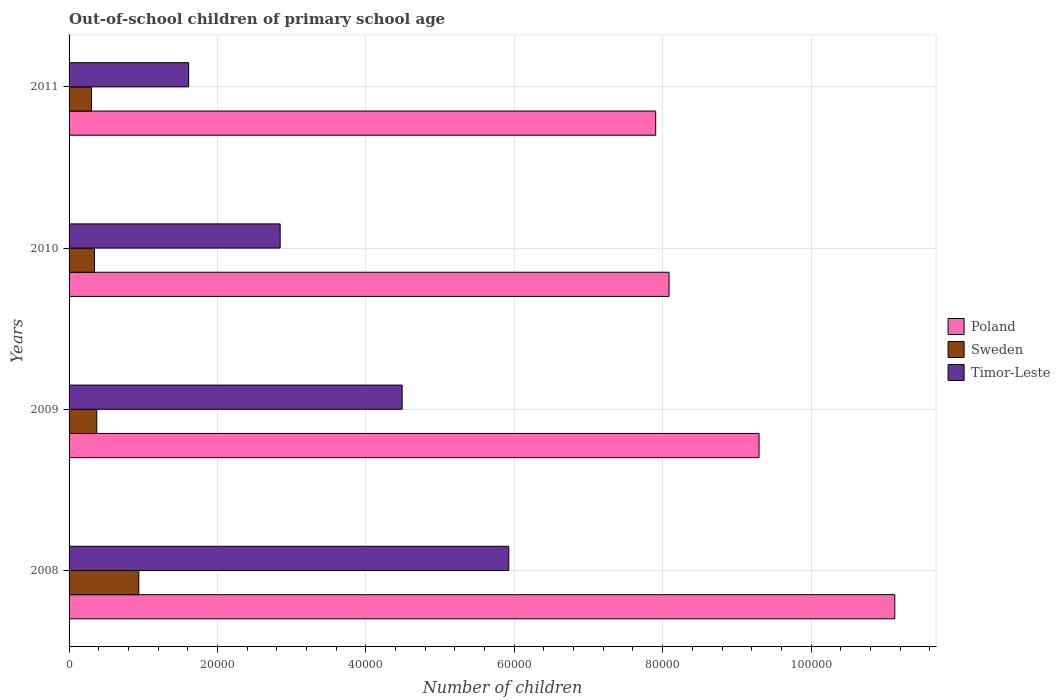How many different coloured bars are there?
Your answer should be very brief. 3. Are the number of bars per tick equal to the number of legend labels?
Offer a very short reply. Yes. Are the number of bars on each tick of the Y-axis equal?
Provide a short and direct response. Yes. What is the number of out-of-school children in Sweden in 2008?
Keep it short and to the point. 9399. Across all years, what is the maximum number of out-of-school children in Poland?
Offer a very short reply. 1.11e+05. Across all years, what is the minimum number of out-of-school children in Poland?
Offer a very short reply. 7.91e+04. In which year was the number of out-of-school children in Timor-Leste maximum?
Your response must be concise. 2008. In which year was the number of out-of-school children in Timor-Leste minimum?
Provide a short and direct response. 2011. What is the total number of out-of-school children in Poland in the graph?
Your response must be concise. 3.64e+05. What is the difference between the number of out-of-school children in Sweden in 2008 and that in 2011?
Provide a succinct answer. 6372. What is the difference between the number of out-of-school children in Poland in 2010 and the number of out-of-school children in Sweden in 2011?
Give a very brief answer. 7.78e+04. What is the average number of out-of-school children in Poland per year?
Your answer should be compact. 9.11e+04. In the year 2011, what is the difference between the number of out-of-school children in Timor-Leste and number of out-of-school children in Sweden?
Offer a very short reply. 1.31e+04. What is the ratio of the number of out-of-school children in Poland in 2008 to that in 2011?
Offer a terse response. 1.41. Is the difference between the number of out-of-school children in Timor-Leste in 2008 and 2010 greater than the difference between the number of out-of-school children in Sweden in 2008 and 2010?
Give a very brief answer. Yes. What is the difference between the highest and the second highest number of out-of-school children in Timor-Leste?
Your answer should be compact. 1.44e+04. What is the difference between the highest and the lowest number of out-of-school children in Sweden?
Provide a succinct answer. 6372. In how many years, is the number of out-of-school children in Sweden greater than the average number of out-of-school children in Sweden taken over all years?
Your response must be concise. 1. Is the sum of the number of out-of-school children in Poland in 2009 and 2011 greater than the maximum number of out-of-school children in Timor-Leste across all years?
Make the answer very short. Yes. What does the 1st bar from the top in 2011 represents?
Give a very brief answer. Timor-Leste. Are all the bars in the graph horizontal?
Give a very brief answer. Yes. What is the difference between two consecutive major ticks on the X-axis?
Give a very brief answer. 2.00e+04. Are the values on the major ticks of X-axis written in scientific E-notation?
Your answer should be very brief. No. Does the graph contain grids?
Keep it short and to the point. Yes. What is the title of the graph?
Offer a terse response. Out-of-school children of primary school age. Does "Slovak Republic" appear as one of the legend labels in the graph?
Ensure brevity in your answer.  No. What is the label or title of the X-axis?
Offer a terse response. Number of children. What is the Number of children of Poland in 2008?
Provide a short and direct response. 1.11e+05. What is the Number of children in Sweden in 2008?
Offer a very short reply. 9399. What is the Number of children in Timor-Leste in 2008?
Offer a terse response. 5.93e+04. What is the Number of children of Poland in 2009?
Ensure brevity in your answer.  9.30e+04. What is the Number of children of Sweden in 2009?
Your response must be concise. 3732. What is the Number of children of Timor-Leste in 2009?
Offer a terse response. 4.49e+04. What is the Number of children of Poland in 2010?
Your answer should be very brief. 8.09e+04. What is the Number of children in Sweden in 2010?
Your response must be concise. 3428. What is the Number of children in Timor-Leste in 2010?
Offer a very short reply. 2.84e+04. What is the Number of children of Poland in 2011?
Make the answer very short. 7.91e+04. What is the Number of children of Sweden in 2011?
Your answer should be compact. 3027. What is the Number of children of Timor-Leste in 2011?
Ensure brevity in your answer.  1.61e+04. Across all years, what is the maximum Number of children in Poland?
Provide a succinct answer. 1.11e+05. Across all years, what is the maximum Number of children in Sweden?
Give a very brief answer. 9399. Across all years, what is the maximum Number of children of Timor-Leste?
Your answer should be very brief. 5.93e+04. Across all years, what is the minimum Number of children of Poland?
Keep it short and to the point. 7.91e+04. Across all years, what is the minimum Number of children of Sweden?
Keep it short and to the point. 3027. Across all years, what is the minimum Number of children of Timor-Leste?
Make the answer very short. 1.61e+04. What is the total Number of children of Poland in the graph?
Your answer should be compact. 3.64e+05. What is the total Number of children in Sweden in the graph?
Keep it short and to the point. 1.96e+04. What is the total Number of children of Timor-Leste in the graph?
Make the answer very short. 1.49e+05. What is the difference between the Number of children in Poland in 2008 and that in 2009?
Your response must be concise. 1.83e+04. What is the difference between the Number of children in Sweden in 2008 and that in 2009?
Your answer should be very brief. 5667. What is the difference between the Number of children in Timor-Leste in 2008 and that in 2009?
Offer a very short reply. 1.44e+04. What is the difference between the Number of children in Poland in 2008 and that in 2010?
Ensure brevity in your answer.  3.04e+04. What is the difference between the Number of children in Sweden in 2008 and that in 2010?
Give a very brief answer. 5971. What is the difference between the Number of children of Timor-Leste in 2008 and that in 2010?
Keep it short and to the point. 3.08e+04. What is the difference between the Number of children in Poland in 2008 and that in 2011?
Your answer should be compact. 3.22e+04. What is the difference between the Number of children in Sweden in 2008 and that in 2011?
Your answer should be very brief. 6372. What is the difference between the Number of children of Timor-Leste in 2008 and that in 2011?
Offer a very short reply. 4.31e+04. What is the difference between the Number of children of Poland in 2009 and that in 2010?
Provide a short and direct response. 1.21e+04. What is the difference between the Number of children in Sweden in 2009 and that in 2010?
Your answer should be very brief. 304. What is the difference between the Number of children in Timor-Leste in 2009 and that in 2010?
Ensure brevity in your answer.  1.64e+04. What is the difference between the Number of children in Poland in 2009 and that in 2011?
Your answer should be very brief. 1.39e+04. What is the difference between the Number of children of Sweden in 2009 and that in 2011?
Provide a short and direct response. 705. What is the difference between the Number of children of Timor-Leste in 2009 and that in 2011?
Your answer should be compact. 2.88e+04. What is the difference between the Number of children of Poland in 2010 and that in 2011?
Your response must be concise. 1799. What is the difference between the Number of children of Sweden in 2010 and that in 2011?
Ensure brevity in your answer.  401. What is the difference between the Number of children of Timor-Leste in 2010 and that in 2011?
Make the answer very short. 1.23e+04. What is the difference between the Number of children of Poland in 2008 and the Number of children of Sweden in 2009?
Your answer should be compact. 1.08e+05. What is the difference between the Number of children of Poland in 2008 and the Number of children of Timor-Leste in 2009?
Keep it short and to the point. 6.64e+04. What is the difference between the Number of children in Sweden in 2008 and the Number of children in Timor-Leste in 2009?
Your response must be concise. -3.55e+04. What is the difference between the Number of children of Poland in 2008 and the Number of children of Sweden in 2010?
Your answer should be compact. 1.08e+05. What is the difference between the Number of children in Poland in 2008 and the Number of children in Timor-Leste in 2010?
Provide a succinct answer. 8.28e+04. What is the difference between the Number of children in Sweden in 2008 and the Number of children in Timor-Leste in 2010?
Your answer should be compact. -1.90e+04. What is the difference between the Number of children of Poland in 2008 and the Number of children of Sweden in 2011?
Offer a terse response. 1.08e+05. What is the difference between the Number of children in Poland in 2008 and the Number of children in Timor-Leste in 2011?
Make the answer very short. 9.52e+04. What is the difference between the Number of children in Sweden in 2008 and the Number of children in Timor-Leste in 2011?
Your answer should be compact. -6718. What is the difference between the Number of children of Poland in 2009 and the Number of children of Sweden in 2010?
Your answer should be very brief. 8.96e+04. What is the difference between the Number of children of Poland in 2009 and the Number of children of Timor-Leste in 2010?
Provide a succinct answer. 6.45e+04. What is the difference between the Number of children of Sweden in 2009 and the Number of children of Timor-Leste in 2010?
Make the answer very short. -2.47e+04. What is the difference between the Number of children in Poland in 2009 and the Number of children in Sweden in 2011?
Your answer should be compact. 9.00e+04. What is the difference between the Number of children of Poland in 2009 and the Number of children of Timor-Leste in 2011?
Offer a terse response. 7.69e+04. What is the difference between the Number of children of Sweden in 2009 and the Number of children of Timor-Leste in 2011?
Provide a succinct answer. -1.24e+04. What is the difference between the Number of children in Poland in 2010 and the Number of children in Sweden in 2011?
Provide a succinct answer. 7.78e+04. What is the difference between the Number of children in Poland in 2010 and the Number of children in Timor-Leste in 2011?
Ensure brevity in your answer.  6.47e+04. What is the difference between the Number of children in Sweden in 2010 and the Number of children in Timor-Leste in 2011?
Offer a terse response. -1.27e+04. What is the average Number of children in Poland per year?
Your answer should be compact. 9.11e+04. What is the average Number of children of Sweden per year?
Provide a short and direct response. 4896.5. What is the average Number of children in Timor-Leste per year?
Your response must be concise. 3.72e+04. In the year 2008, what is the difference between the Number of children in Poland and Number of children in Sweden?
Provide a short and direct response. 1.02e+05. In the year 2008, what is the difference between the Number of children in Poland and Number of children in Timor-Leste?
Your answer should be very brief. 5.20e+04. In the year 2008, what is the difference between the Number of children of Sweden and Number of children of Timor-Leste?
Your response must be concise. -4.99e+04. In the year 2009, what is the difference between the Number of children of Poland and Number of children of Sweden?
Keep it short and to the point. 8.93e+04. In the year 2009, what is the difference between the Number of children in Poland and Number of children in Timor-Leste?
Provide a succinct answer. 4.81e+04. In the year 2009, what is the difference between the Number of children of Sweden and Number of children of Timor-Leste?
Provide a succinct answer. -4.12e+04. In the year 2010, what is the difference between the Number of children in Poland and Number of children in Sweden?
Offer a terse response. 7.74e+04. In the year 2010, what is the difference between the Number of children in Poland and Number of children in Timor-Leste?
Your answer should be very brief. 5.24e+04. In the year 2010, what is the difference between the Number of children in Sweden and Number of children in Timor-Leste?
Your answer should be very brief. -2.50e+04. In the year 2011, what is the difference between the Number of children of Poland and Number of children of Sweden?
Make the answer very short. 7.60e+04. In the year 2011, what is the difference between the Number of children of Poland and Number of children of Timor-Leste?
Your answer should be compact. 6.29e+04. In the year 2011, what is the difference between the Number of children of Sweden and Number of children of Timor-Leste?
Give a very brief answer. -1.31e+04. What is the ratio of the Number of children in Poland in 2008 to that in 2009?
Provide a succinct answer. 1.2. What is the ratio of the Number of children in Sweden in 2008 to that in 2009?
Make the answer very short. 2.52. What is the ratio of the Number of children of Timor-Leste in 2008 to that in 2009?
Make the answer very short. 1.32. What is the ratio of the Number of children of Poland in 2008 to that in 2010?
Ensure brevity in your answer.  1.38. What is the ratio of the Number of children in Sweden in 2008 to that in 2010?
Your answer should be compact. 2.74. What is the ratio of the Number of children of Timor-Leste in 2008 to that in 2010?
Provide a succinct answer. 2.08. What is the ratio of the Number of children in Poland in 2008 to that in 2011?
Provide a succinct answer. 1.41. What is the ratio of the Number of children of Sweden in 2008 to that in 2011?
Offer a very short reply. 3.11. What is the ratio of the Number of children of Timor-Leste in 2008 to that in 2011?
Your answer should be very brief. 3.68. What is the ratio of the Number of children in Poland in 2009 to that in 2010?
Ensure brevity in your answer.  1.15. What is the ratio of the Number of children of Sweden in 2009 to that in 2010?
Ensure brevity in your answer.  1.09. What is the ratio of the Number of children of Timor-Leste in 2009 to that in 2010?
Offer a very short reply. 1.58. What is the ratio of the Number of children of Poland in 2009 to that in 2011?
Provide a succinct answer. 1.18. What is the ratio of the Number of children of Sweden in 2009 to that in 2011?
Make the answer very short. 1.23. What is the ratio of the Number of children of Timor-Leste in 2009 to that in 2011?
Keep it short and to the point. 2.79. What is the ratio of the Number of children in Poland in 2010 to that in 2011?
Your answer should be compact. 1.02. What is the ratio of the Number of children of Sweden in 2010 to that in 2011?
Your answer should be very brief. 1.13. What is the ratio of the Number of children of Timor-Leste in 2010 to that in 2011?
Provide a short and direct response. 1.77. What is the difference between the highest and the second highest Number of children of Poland?
Make the answer very short. 1.83e+04. What is the difference between the highest and the second highest Number of children of Sweden?
Provide a succinct answer. 5667. What is the difference between the highest and the second highest Number of children of Timor-Leste?
Your answer should be compact. 1.44e+04. What is the difference between the highest and the lowest Number of children in Poland?
Provide a succinct answer. 3.22e+04. What is the difference between the highest and the lowest Number of children in Sweden?
Your response must be concise. 6372. What is the difference between the highest and the lowest Number of children in Timor-Leste?
Provide a succinct answer. 4.31e+04. 